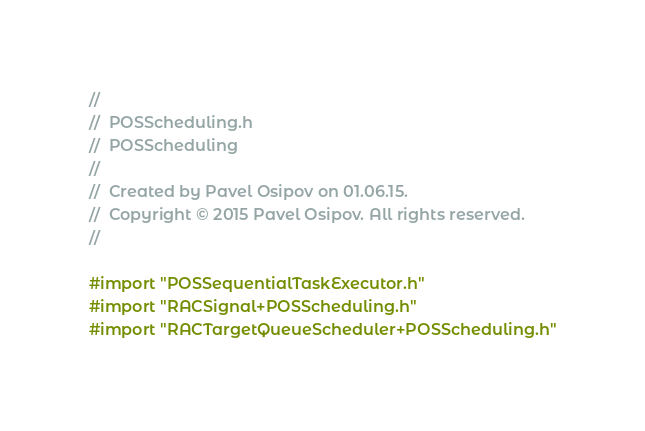<code> <loc_0><loc_0><loc_500><loc_500><_C_>//
//  POSScheduling.h
//  POSScheduling
//
//  Created by Pavel Osipov on 01.06.15.
//  Copyright © 2015 Pavel Osipov. All rights reserved.
//

#import "POSSequentialTaskExecutor.h"
#import "RACSignal+POSScheduling.h"
#import "RACTargetQueueScheduler+POSScheduling.h"
</code> 